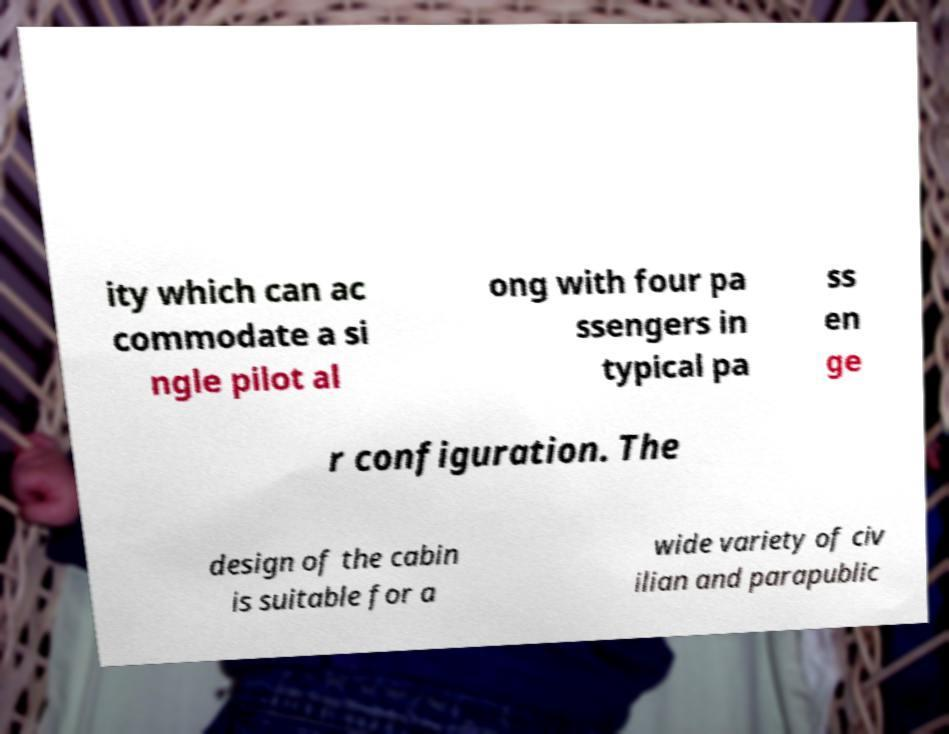There's text embedded in this image that I need extracted. Can you transcribe it verbatim? ity which can ac commodate a si ngle pilot al ong with four pa ssengers in typical pa ss en ge r configuration. The design of the cabin is suitable for a wide variety of civ ilian and parapublic 